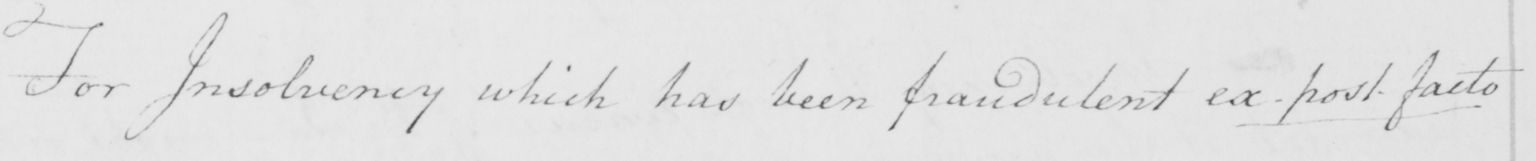What is written in this line of handwriting? For Insolvency which has been fraudulent ex-post-facto 